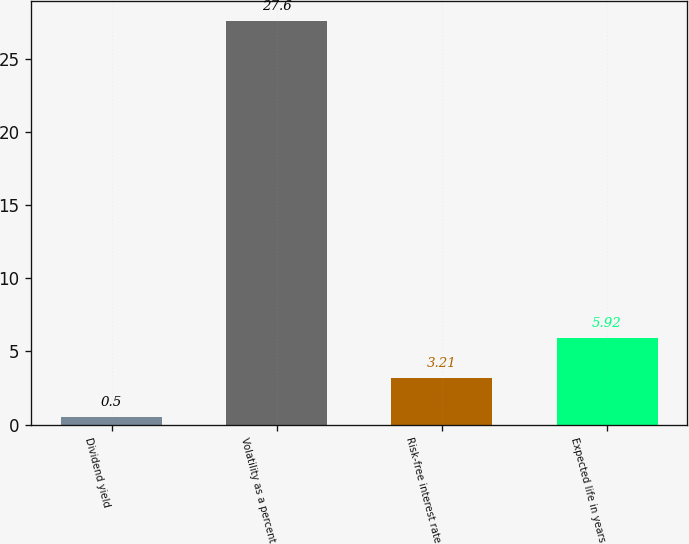Convert chart to OTSL. <chart><loc_0><loc_0><loc_500><loc_500><bar_chart><fcel>Dividend yield<fcel>Volatility as a percent<fcel>Risk-free interest rate<fcel>Expected life in years<nl><fcel>0.5<fcel>27.6<fcel>3.21<fcel>5.92<nl></chart> 